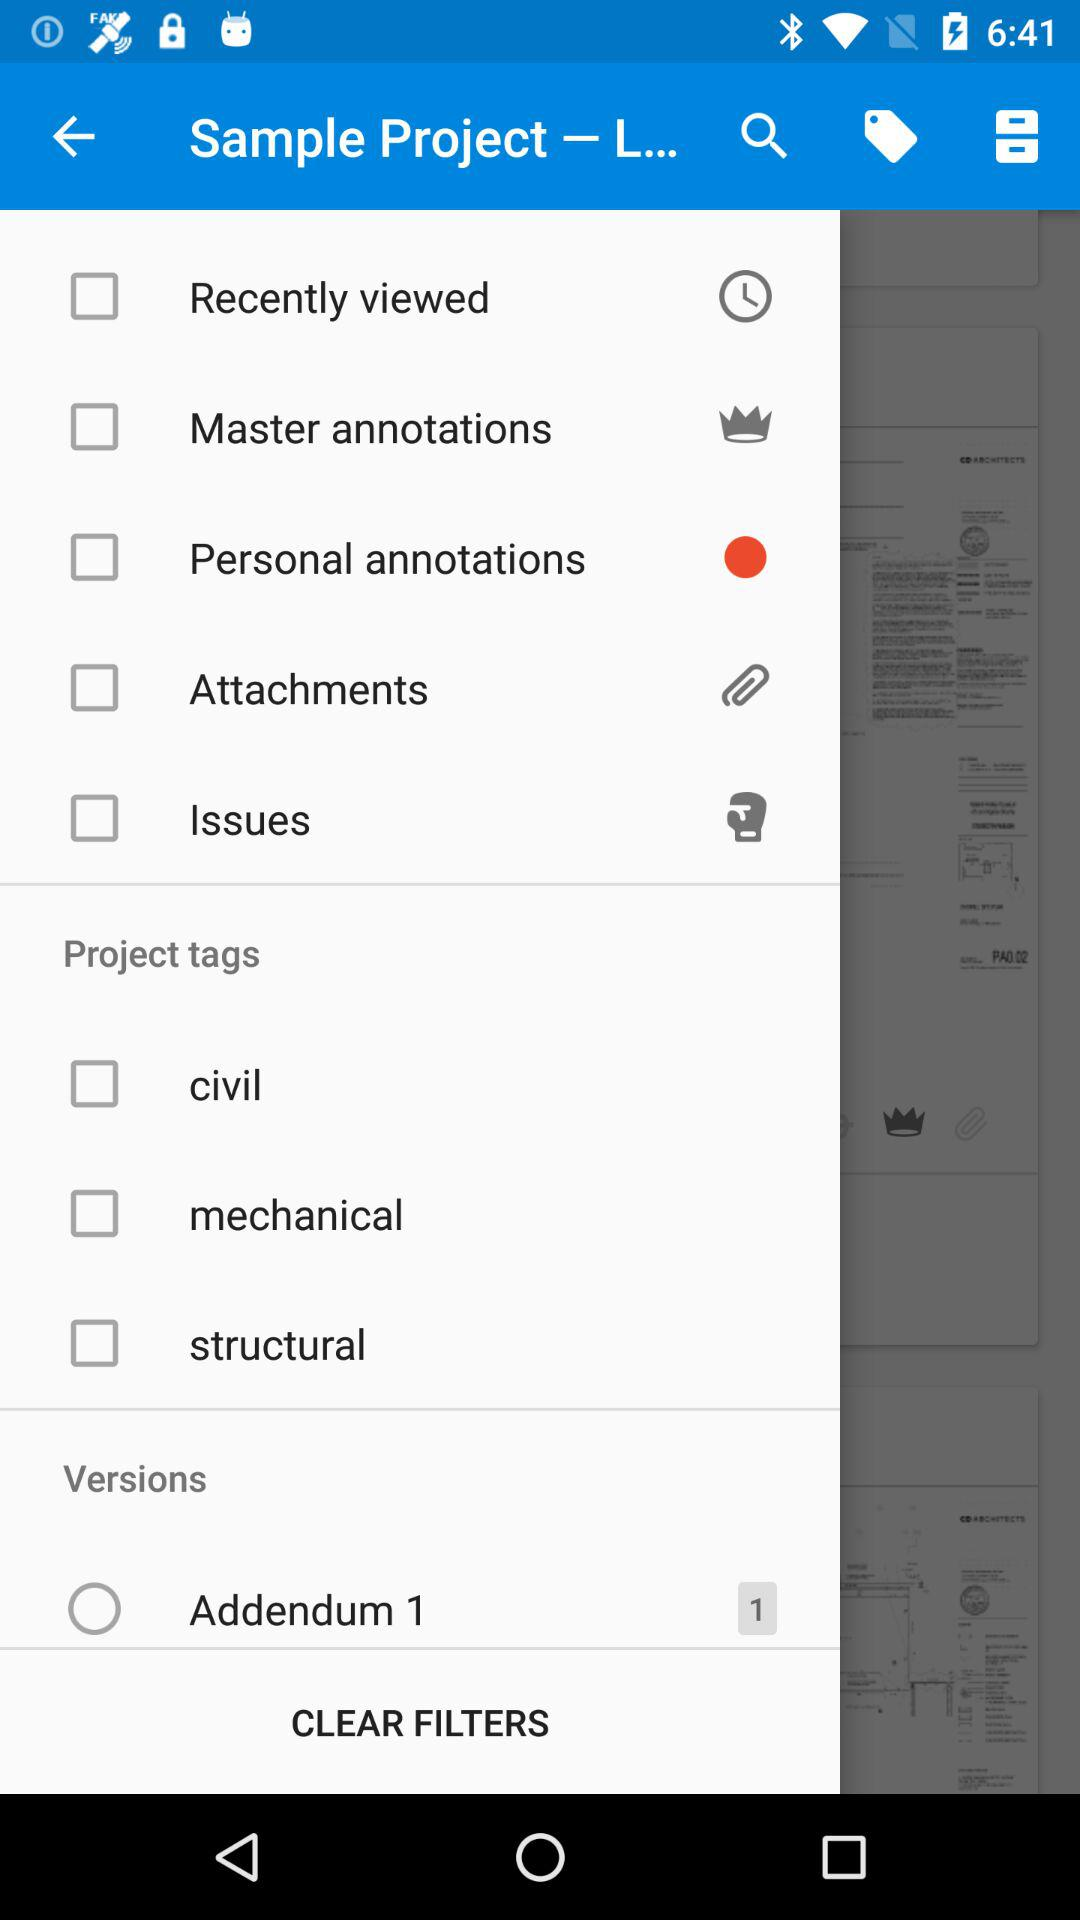What is the name of the application?
When the provided information is insufficient, respond with <no answer>. <no answer> 